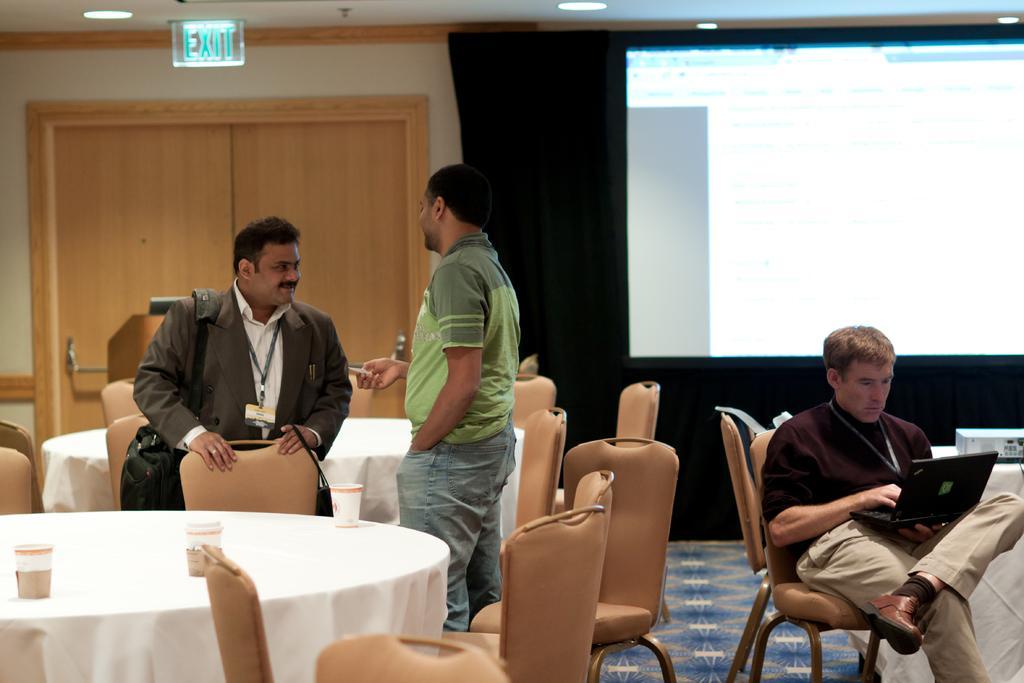In one or two sentences, can you explain what this image depicts? This is the picture of the inside of the room. There are three people. Two persons are sitting and one man is standing. The brown color shirt person is holding like a laptop. His look at the laptop. He's wearing a id card. The standing person is like holding something. The other sitting person is wearing id card. His smiling. There is a table and chair. There is a glass on the table. We can see in the background there is a projector,cupboard and lights. 